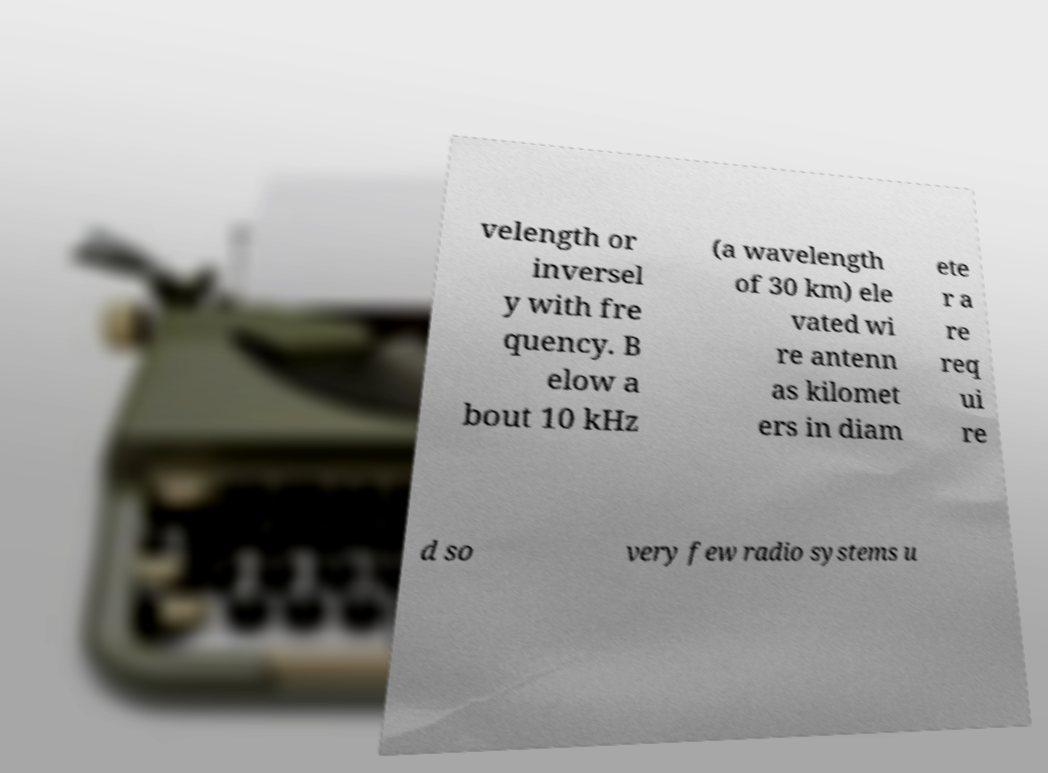Can you accurately transcribe the text from the provided image for me? velength or inversel y with fre quency. B elow a bout 10 kHz (a wavelength of 30 km) ele vated wi re antenn as kilomet ers in diam ete r a re req ui re d so very few radio systems u 